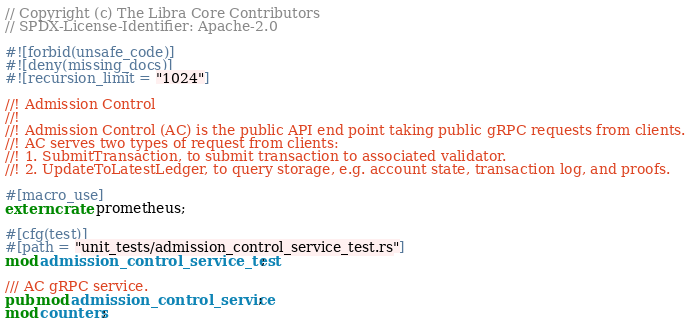Convert code to text. <code><loc_0><loc_0><loc_500><loc_500><_Rust_>// Copyright (c) The Libra Core Contributors
// SPDX-License-Identifier: Apache-2.0

#![forbid(unsafe_code)]
#![deny(missing_docs)]
#![recursion_limit = "1024"]

//! Admission Control
//!
//! Admission Control (AC) is the public API end point taking public gRPC requests from clients.
//! AC serves two types of request from clients:
//! 1. SubmitTransaction, to submit transaction to associated validator.
//! 2. UpdateToLatestLedger, to query storage, e.g. account state, transaction log, and proofs.

#[macro_use]
extern crate prometheus;

#[cfg(test)]
#[path = "unit_tests/admission_control_service_test.rs"]
mod admission_control_service_test;

/// AC gRPC service.
pub mod admission_control_service;
mod counters;
</code> 